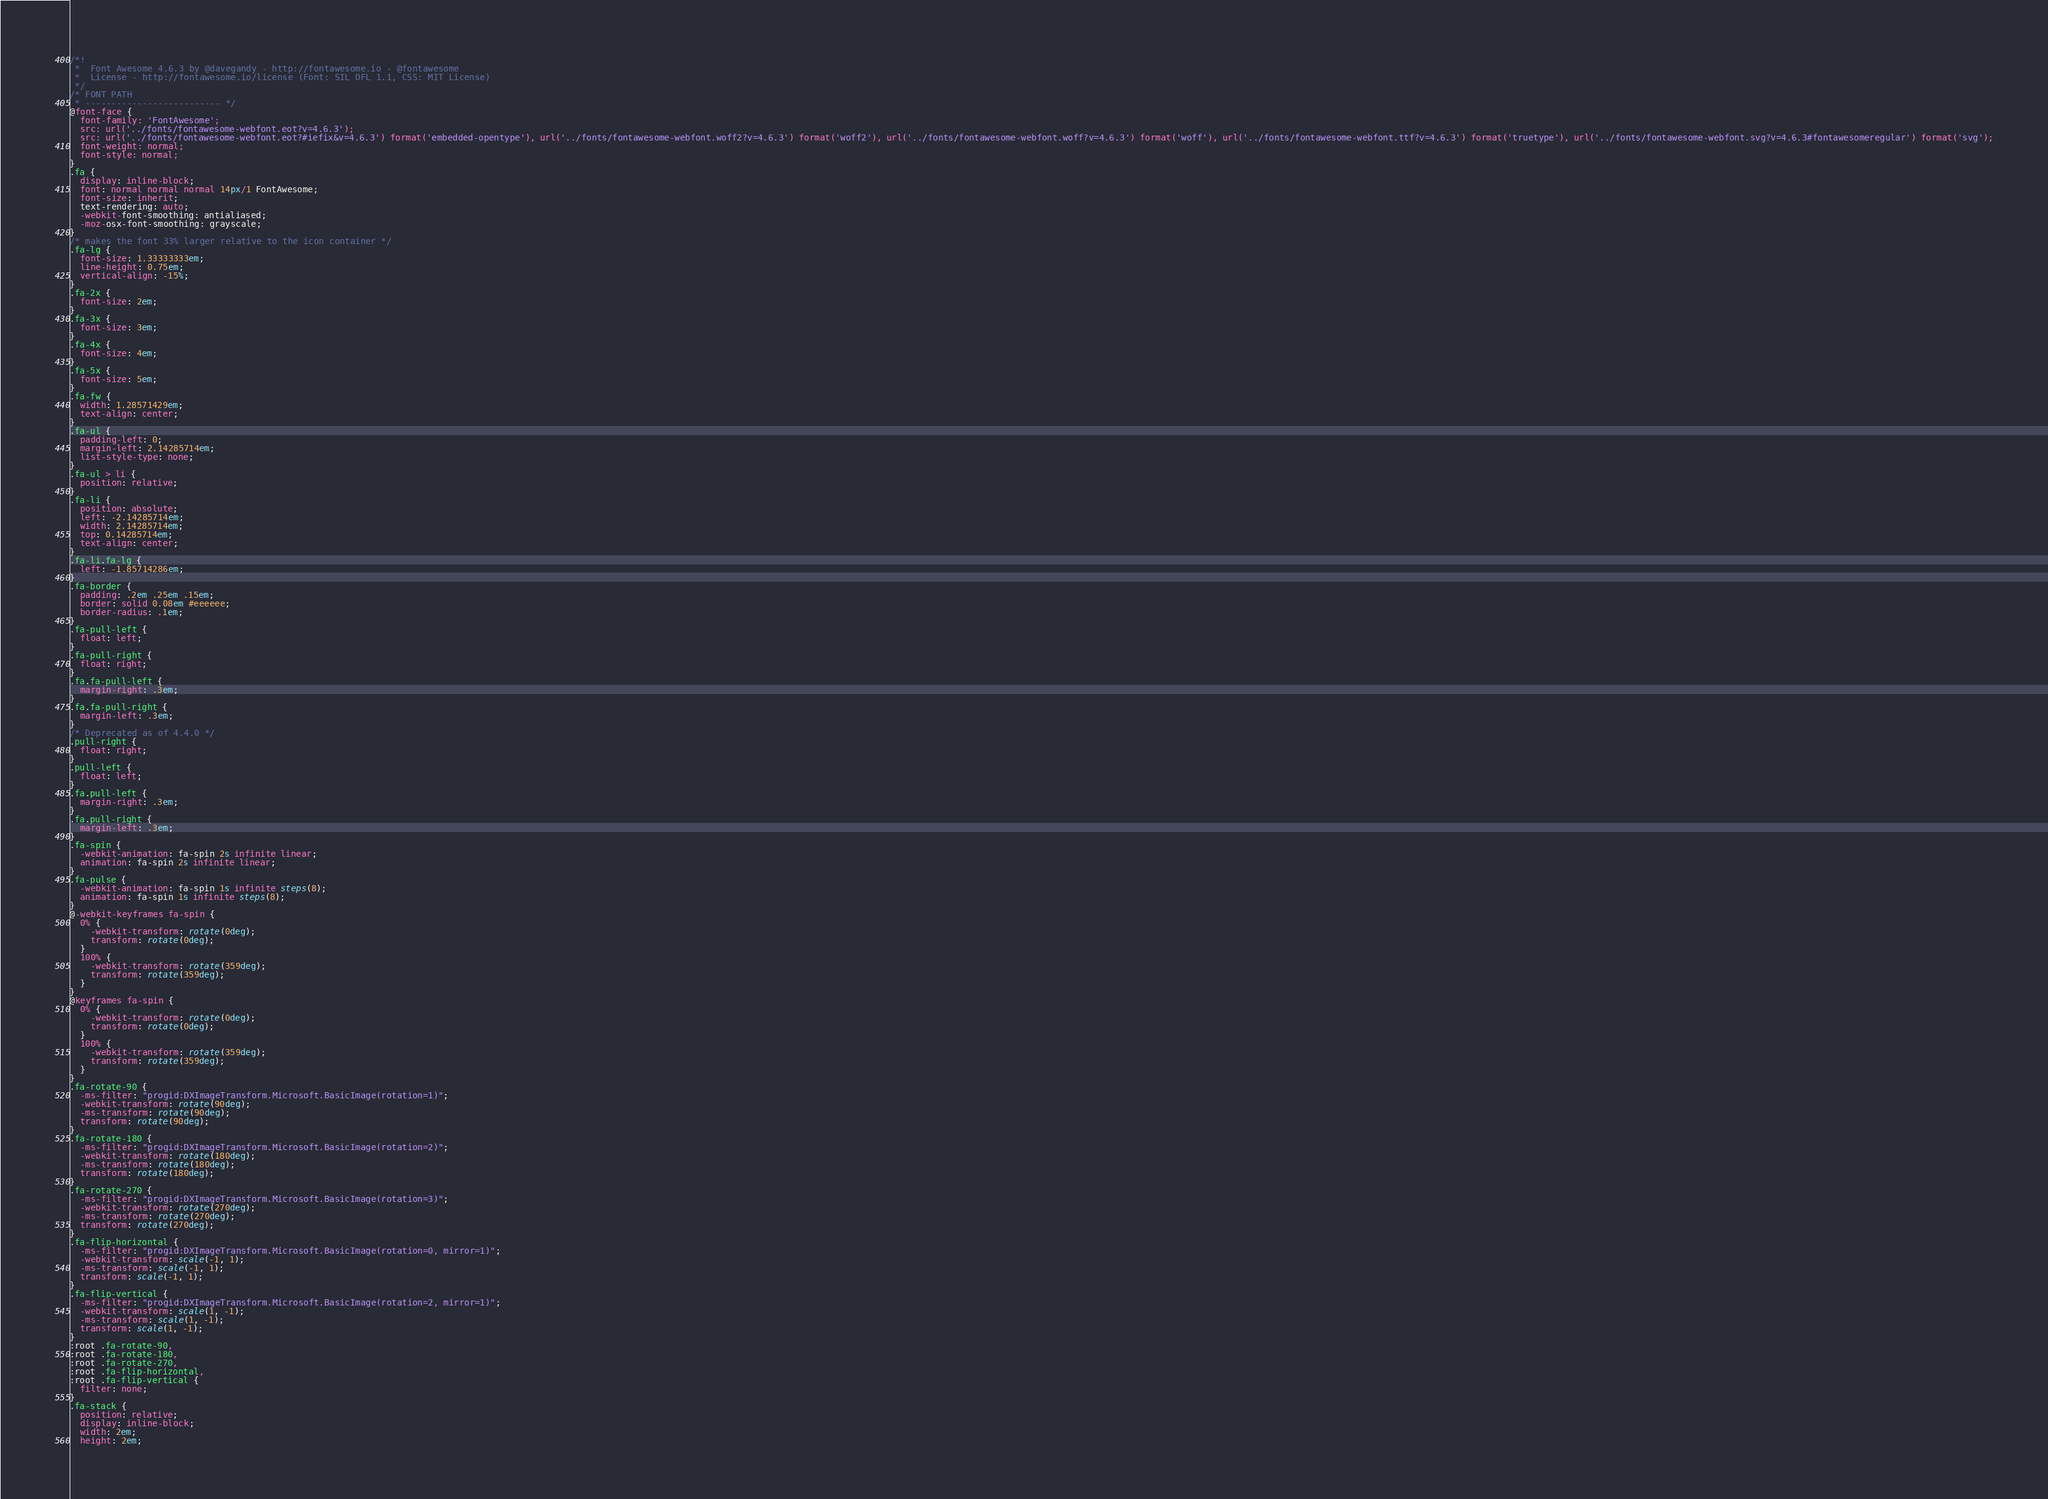Convert code to text. <code><loc_0><loc_0><loc_500><loc_500><_CSS_>/*!
 *  Font Awesome 4.6.3 by @davegandy - http://fontawesome.io - @fontawesome
 *  License - http://fontawesome.io/license (Font: SIL OFL 1.1, CSS: MIT License)
 */
/* FONT PATH
 * -------------------------- */
@font-face {
  font-family: 'FontAwesome';
  src: url('../fonts/fontawesome-webfont.eot?v=4.6.3');
  src: url('../fonts/fontawesome-webfont.eot?#iefix&v=4.6.3') format('embedded-opentype'), url('../fonts/fontawesome-webfont.woff2?v=4.6.3') format('woff2'), url('../fonts/fontawesome-webfont.woff?v=4.6.3') format('woff'), url('../fonts/fontawesome-webfont.ttf?v=4.6.3') format('truetype'), url('../fonts/fontawesome-webfont.svg?v=4.6.3#fontawesomeregular') format('svg');
  font-weight: normal;
  font-style: normal;
}
.fa {
  display: inline-block;
  font: normal normal normal 14px/1 FontAwesome;
  font-size: inherit;
  text-rendering: auto;
  -webkit-font-smoothing: antialiased;
  -moz-osx-font-smoothing: grayscale;
}
/* makes the font 33% larger relative to the icon container */
.fa-lg {
  font-size: 1.33333333em;
  line-height: 0.75em;
  vertical-align: -15%;
}
.fa-2x {
  font-size: 2em;
}
.fa-3x {
  font-size: 3em;
}
.fa-4x {
  font-size: 4em;
}
.fa-5x {
  font-size: 5em;
}
.fa-fw {
  width: 1.28571429em;
  text-align: center;
}
.fa-ul {
  padding-left: 0;
  margin-left: 2.14285714em;
  list-style-type: none;
}
.fa-ul > li {
  position: relative;
}
.fa-li {
  position: absolute;
  left: -2.14285714em;
  width: 2.14285714em;
  top: 0.14285714em;
  text-align: center;
}
.fa-li.fa-lg {
  left: -1.85714286em;
}
.fa-border {
  padding: .2em .25em .15em;
  border: solid 0.08em #eeeeee;
  border-radius: .1em;
}
.fa-pull-left {
  float: left;
}
.fa-pull-right {
  float: right;
}
.fa.fa-pull-left {
  margin-right: .3em;
}
.fa.fa-pull-right {
  margin-left: .3em;
}
/* Deprecated as of 4.4.0 */
.pull-right {
  float: right;
}
.pull-left {
  float: left;
}
.fa.pull-left {
  margin-right: .3em;
}
.fa.pull-right {
  margin-left: .3em;
}
.fa-spin {
  -webkit-animation: fa-spin 2s infinite linear;
  animation: fa-spin 2s infinite linear;
}
.fa-pulse {
  -webkit-animation: fa-spin 1s infinite steps(8);
  animation: fa-spin 1s infinite steps(8);
}
@-webkit-keyframes fa-spin {
  0% {
    -webkit-transform: rotate(0deg);
    transform: rotate(0deg);
  }
  100% {
    -webkit-transform: rotate(359deg);
    transform: rotate(359deg);
  }
}
@keyframes fa-spin {
  0% {
    -webkit-transform: rotate(0deg);
    transform: rotate(0deg);
  }
  100% {
    -webkit-transform: rotate(359deg);
    transform: rotate(359deg);
  }
}
.fa-rotate-90 {
  -ms-filter: "progid:DXImageTransform.Microsoft.BasicImage(rotation=1)";
  -webkit-transform: rotate(90deg);
  -ms-transform: rotate(90deg);
  transform: rotate(90deg);
}
.fa-rotate-180 {
  -ms-filter: "progid:DXImageTransform.Microsoft.BasicImage(rotation=2)";
  -webkit-transform: rotate(180deg);
  -ms-transform: rotate(180deg);
  transform: rotate(180deg);
}
.fa-rotate-270 {
  -ms-filter: "progid:DXImageTransform.Microsoft.BasicImage(rotation=3)";
  -webkit-transform: rotate(270deg);
  -ms-transform: rotate(270deg);
  transform: rotate(270deg);
}
.fa-flip-horizontal {
  -ms-filter: "progid:DXImageTransform.Microsoft.BasicImage(rotation=0, mirror=1)";
  -webkit-transform: scale(-1, 1);
  -ms-transform: scale(-1, 1);
  transform: scale(-1, 1);
}
.fa-flip-vertical {
  -ms-filter: "progid:DXImageTransform.Microsoft.BasicImage(rotation=2, mirror=1)";
  -webkit-transform: scale(1, -1);
  -ms-transform: scale(1, -1);
  transform: scale(1, -1);
}
:root .fa-rotate-90,
:root .fa-rotate-180,
:root .fa-rotate-270,
:root .fa-flip-horizontal,
:root .fa-flip-vertical {
  filter: none;
}
.fa-stack {
  position: relative;
  display: inline-block;
  width: 2em;
  height: 2em;</code> 